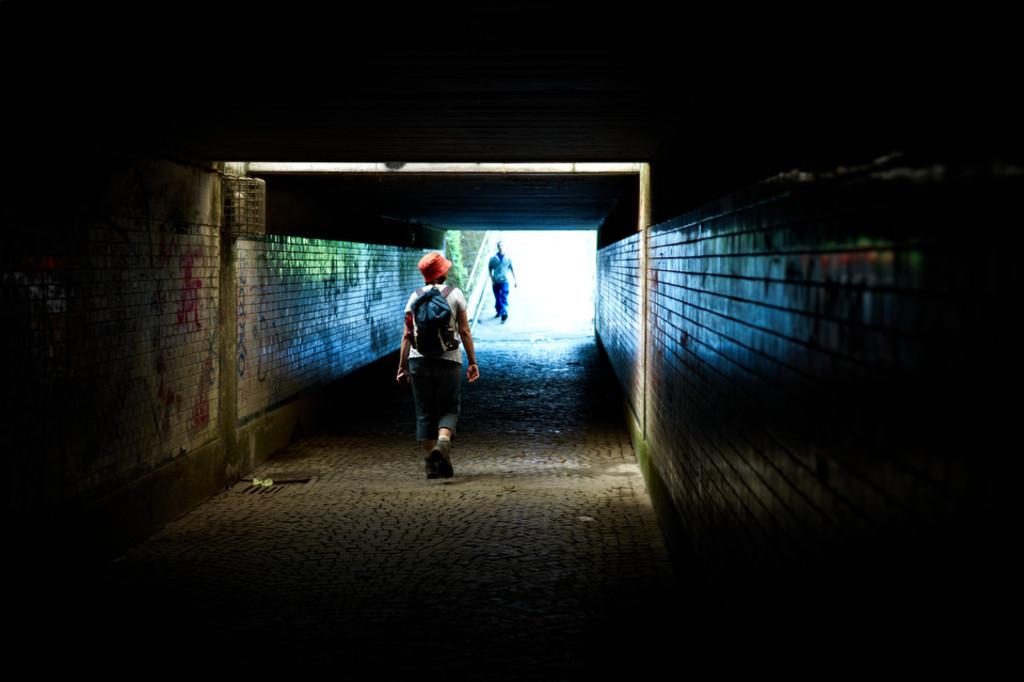How many people are in the image? There are two persons in the image. What are the persons doing in the image? The persons are walking on the road. What type of material is used to construct the walls beside the persons? The walls are made with bricks. What type of airplane can be seen flying in the image? There is no airplane visible in the image; it only features two persons walking on the road and walls made of bricks. 